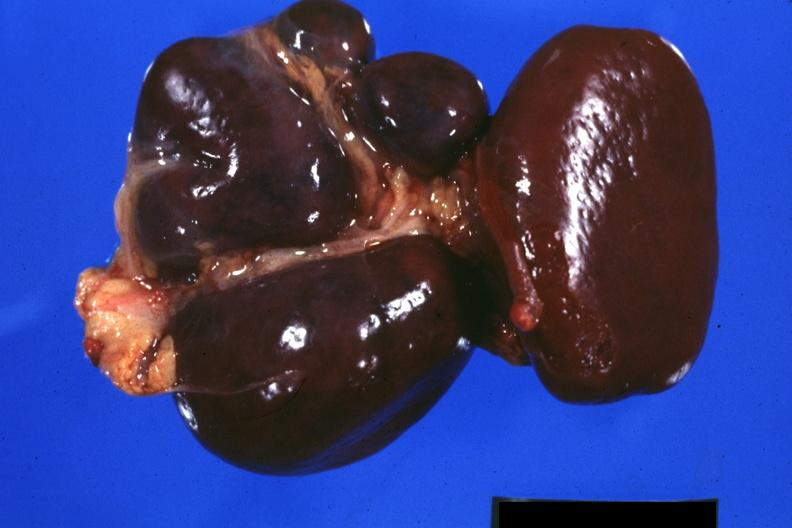where is this part in?
Answer the question using a single word or phrase. Spleen 